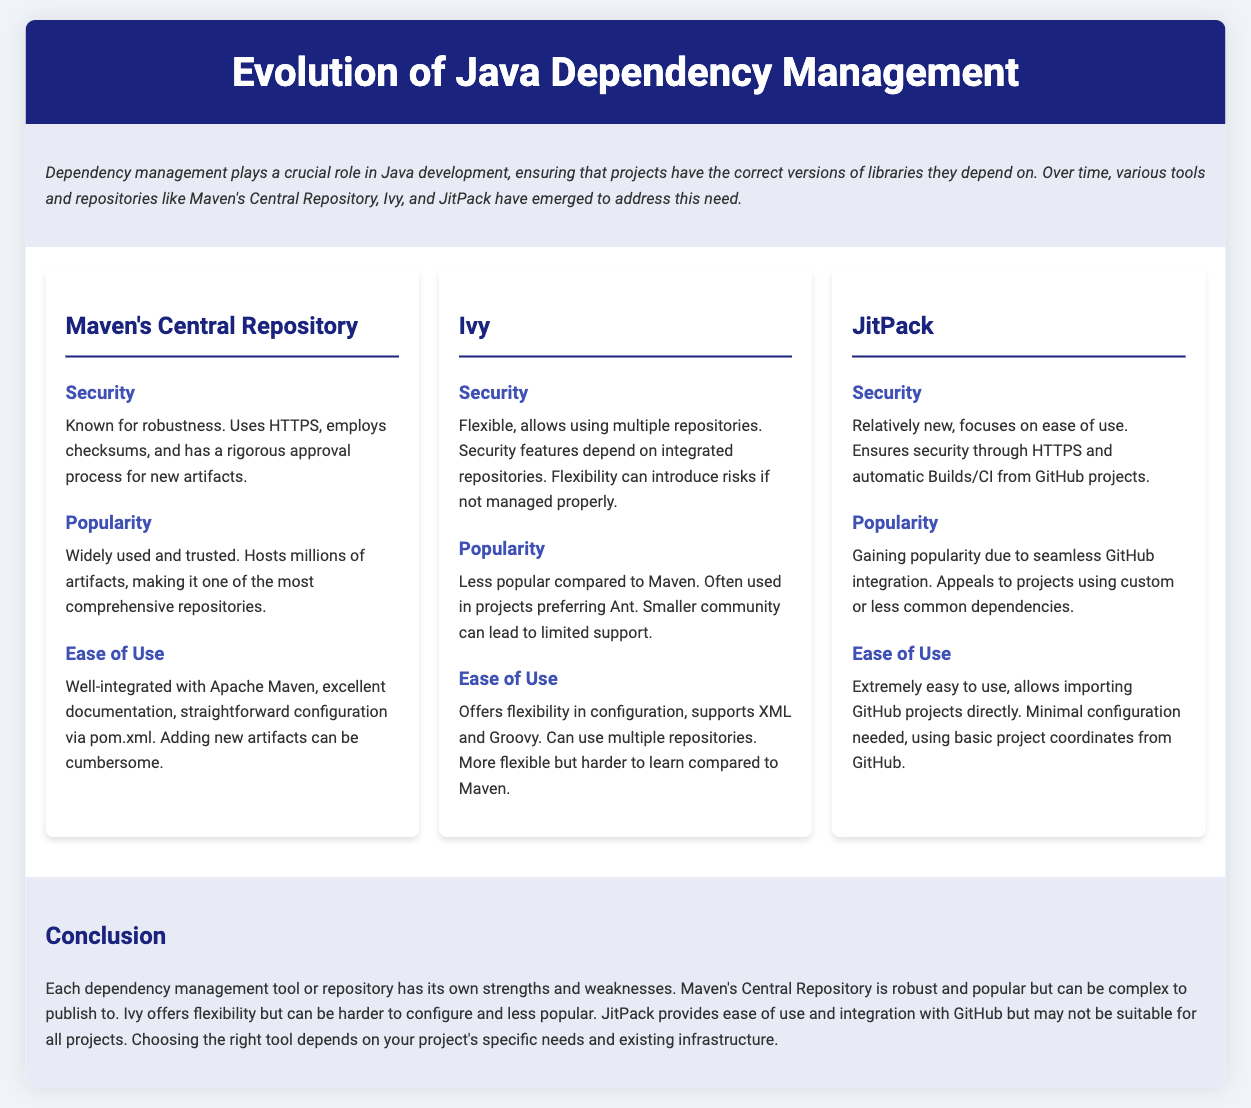What repository is known for robustness? The document states that Maven's Central Repository is known for robustness.
Answer: Maven's Central Repository How does Maven's Central Repository ensure security? The document mentions that it uses HTTPS, employs checksums, and has a rigorous approval process for new artifacts.
Answer: HTTPS, checksums, approval process Which tool has a smaller community leading to limited support? The document indicates that Ivy has a smaller community compared to Maven, which can lead to limited support.
Answer: Ivy What feature does JitPack focus on? The document highlights that JitPack focuses on ease of use.
Answer: Ease of use What integration does JitPack provide? The document states that JitPack offers seamless GitHub integration.
Answer: Seamless GitHub integration Which repository is considered extremely easy to use? The document describes JitPack as extremely easy to use.
Answer: JitPack How does Ivy's security features depend on repositories? The document explains that Ivy's security features depend on the integrated repositories.
Answer: Integrated repositories What is a disadvantage of Maven's Central Repository? The document mentions that adding new artifacts can be cumbersome.
Answer: Cumbersome artifact addition Which tool offers more flexibility but is harder to learn? The document states that Ivy offers more flexibility but is harder to learn compared to Maven.
Answer: Ivy 